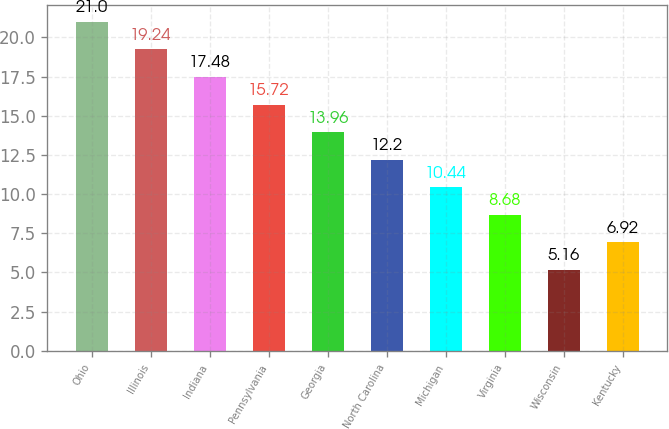<chart> <loc_0><loc_0><loc_500><loc_500><bar_chart><fcel>Ohio<fcel>Illinois<fcel>Indiana<fcel>Pennsylvania<fcel>Georgia<fcel>North Carolina<fcel>Michigan<fcel>Virginia<fcel>Wisconsin<fcel>Kentucky<nl><fcel>21<fcel>19.24<fcel>17.48<fcel>15.72<fcel>13.96<fcel>12.2<fcel>10.44<fcel>8.68<fcel>5.16<fcel>6.92<nl></chart> 